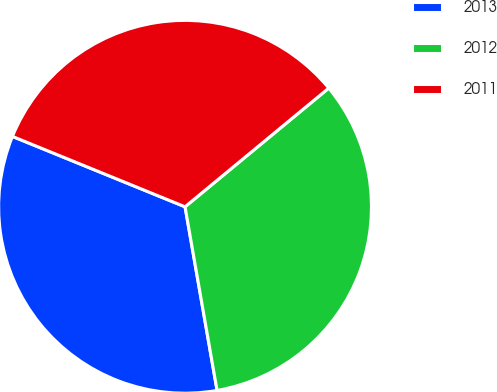Convert chart to OTSL. <chart><loc_0><loc_0><loc_500><loc_500><pie_chart><fcel>2013<fcel>2012<fcel>2011<nl><fcel>33.91%<fcel>33.24%<fcel>32.85%<nl></chart> 